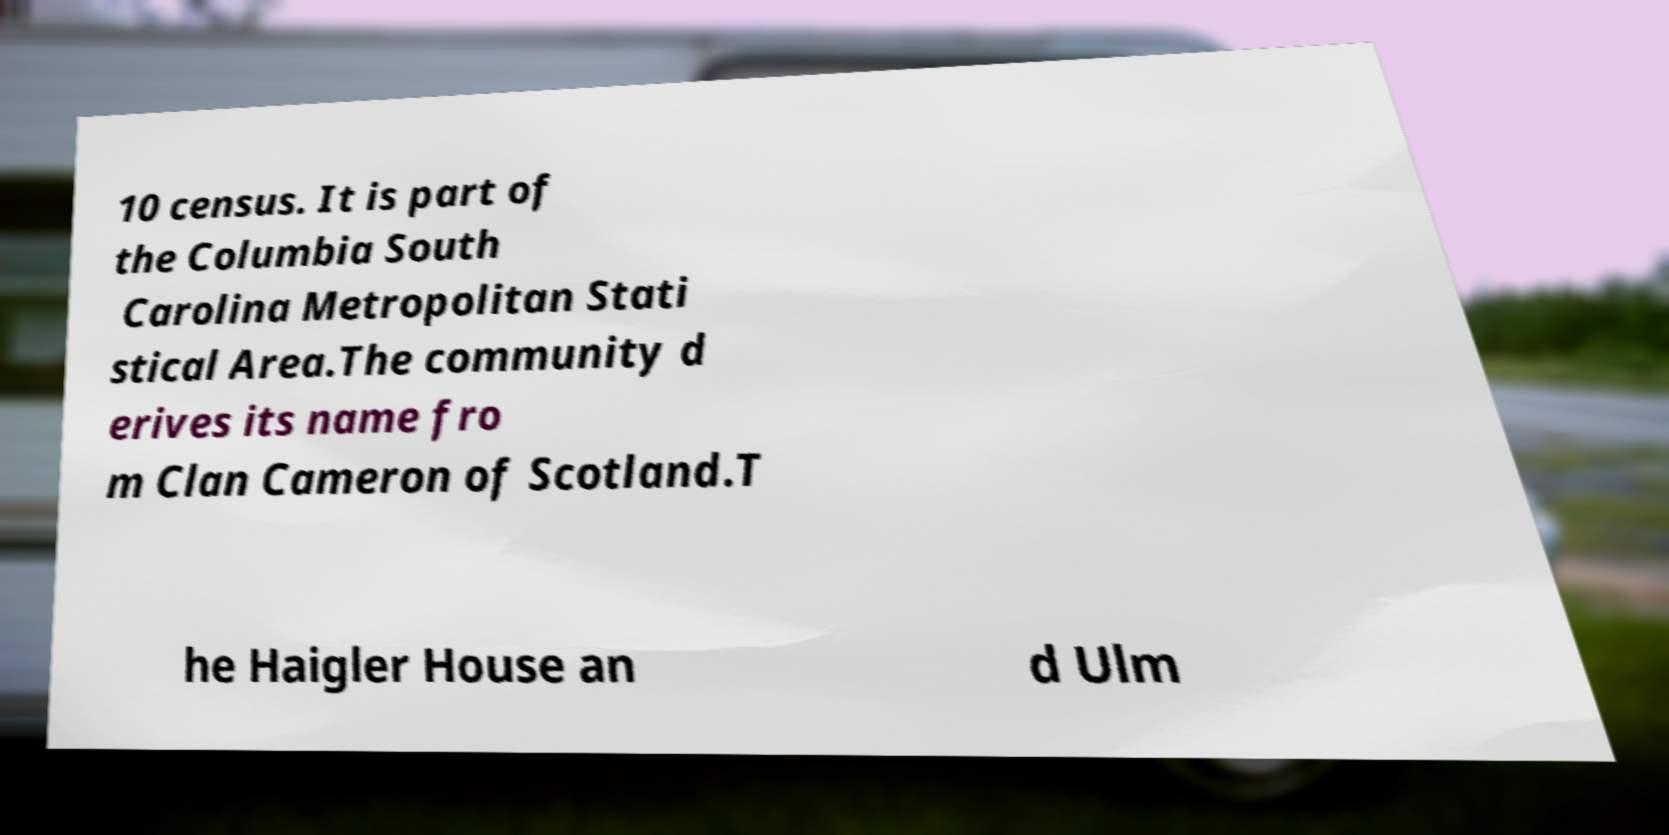Please identify and transcribe the text found in this image. 10 census. It is part of the Columbia South Carolina Metropolitan Stati stical Area.The community d erives its name fro m Clan Cameron of Scotland.T he Haigler House an d Ulm 